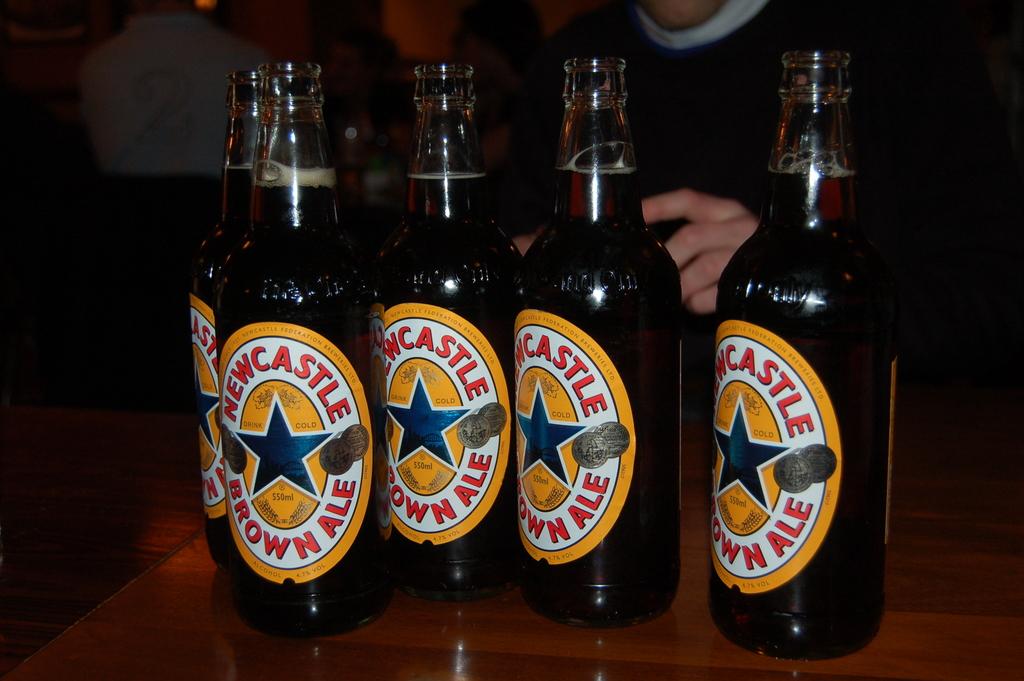What color is the ale?
Keep it short and to the point. Brown. 